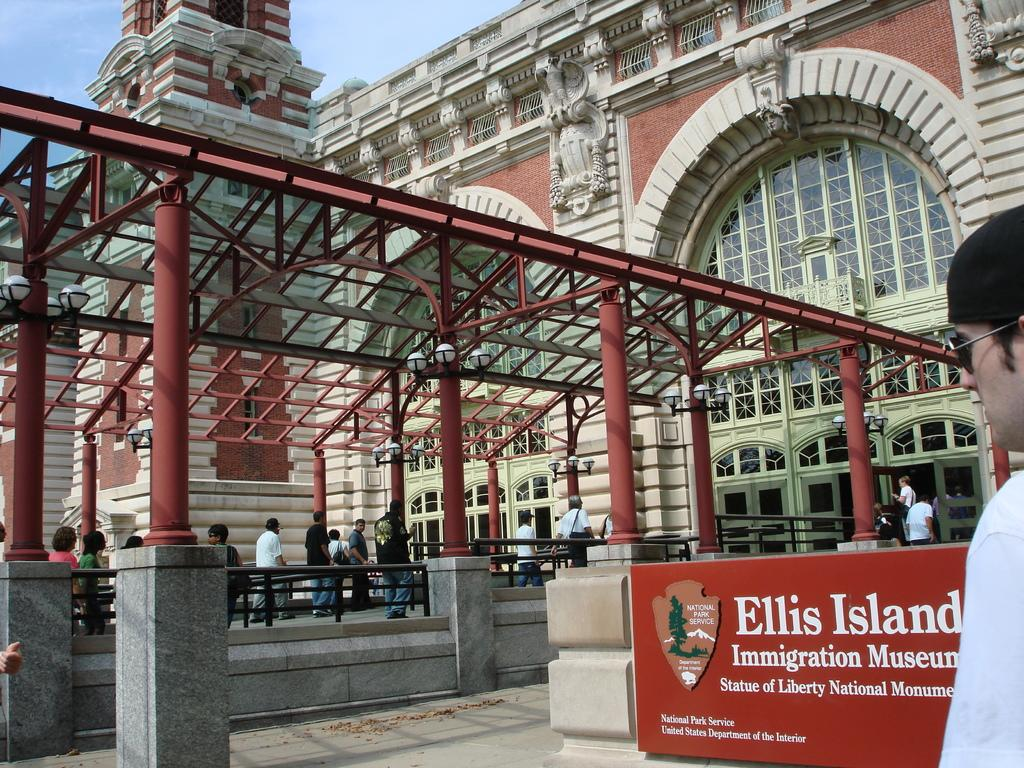What type of structure is visible in the image? There is a building in the image. What are the people in the image doing? There are people walking in the image. Can you describe the man's appearance in the image? The man is wearing sunglasses and a cap in the image. What is written on the wall in the image? There is a name board on the wall in the image. How would you describe the weather based on the sky in the image? The sky is blue and cloudy in the image, suggesting a partly cloudy day. What type of jewel is the man holding in the image? There is no jewel present in the image; the man is wearing sunglasses and a cap. How many sons can be seen in the image? There is no mention of a son or any children in the image. 